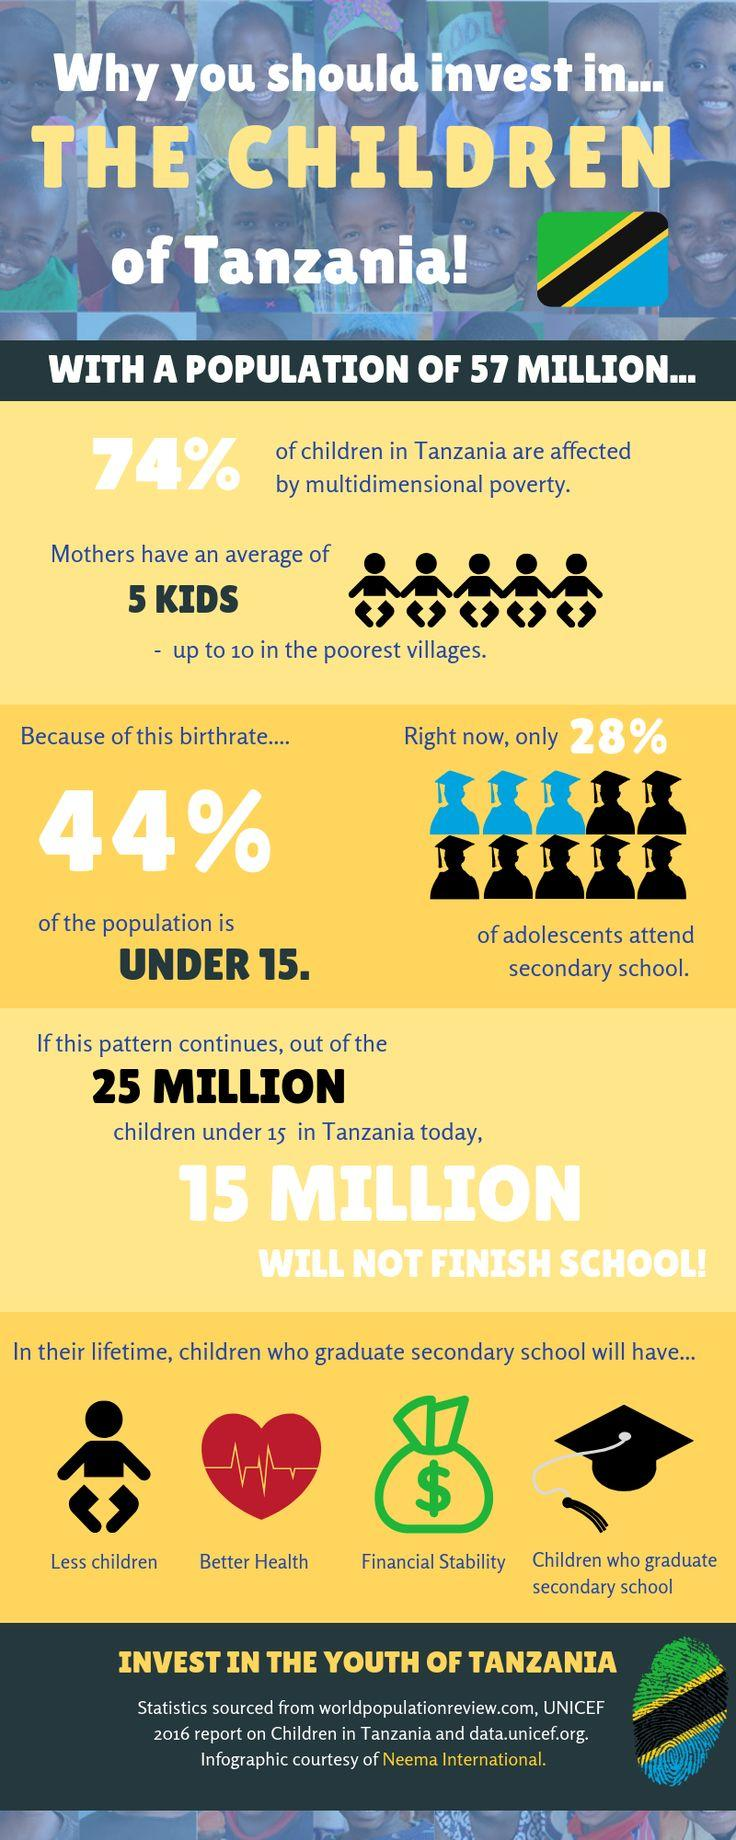Indicate a few pertinent items in this graphic. According to recent data, approximately 26% of children in Tanzania are not affected by multidimensional poverty. According to data, approximately 44% of the population in Tanzania is under the age of 15. 